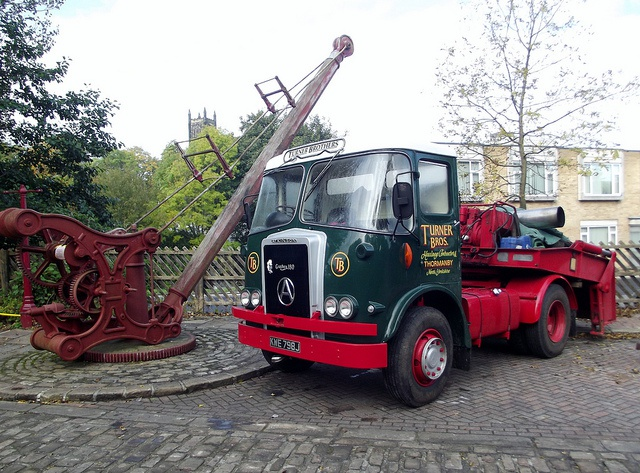Describe the objects in this image and their specific colors. I can see a truck in teal, black, brown, gray, and lightgray tones in this image. 